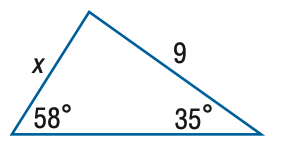Question: Find x. Round the side measure to the nearest tenth.
Choices:
A. 5.2
B. 6.1
C. 13.3
D. 15.7
Answer with the letter. Answer: B 